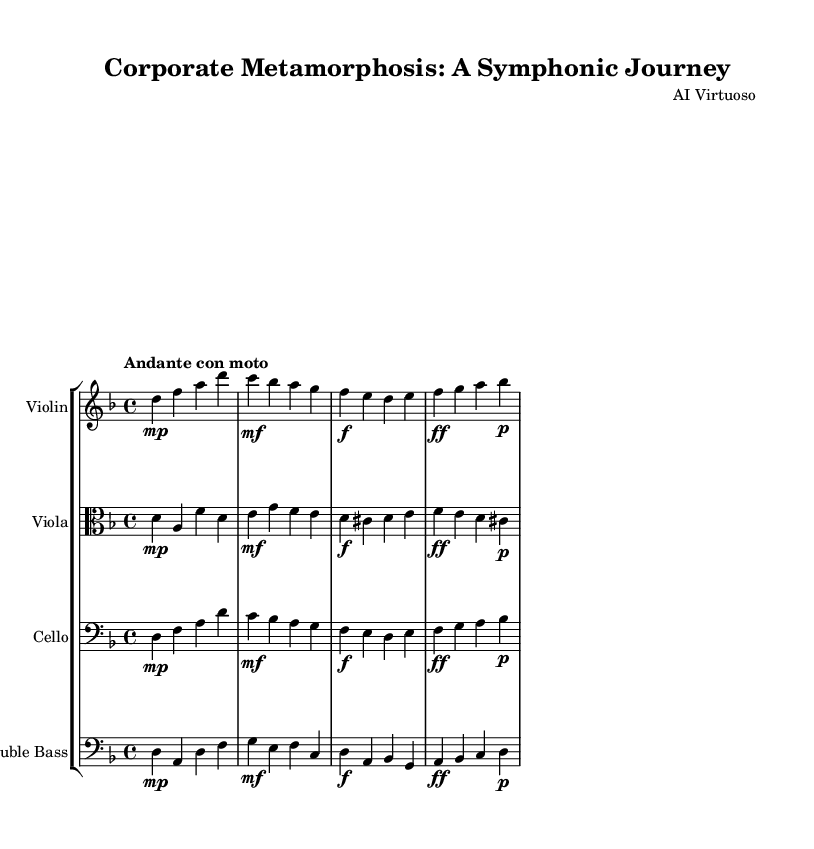what is the key signature of this music? The key signature is indicated near the beginning of the score. In this case, it shows a flat sign, indicating B flat. This corresponds to the key of D minor which has one flat.
Answer: D minor what is the time signature of this music? The time signature is displayed at the beginning of the score, where it shows a '4' over a '4', meaning there are four beats in a measure and each quarter note gets one beat.
Answer: 4/4 what is the tempo marking of this music? The tempo marking is written above the staff following the global section. It reads "Andante con moto," which translates to a moderately slow pace.
Answer: Andante con moto how many instruments are featured in this symphony? To determine this, you can count the number of staves in the score. Each staff represents a different instrument. In this case, there are four staves for four instruments.
Answer: Four which instrument plays the highest pitch in this symphony? The highest pitch is determined by analyzing the range of each instrument. The Violin typically plays at the highest pitch compared to Viola, Cello, and Double Bass, which play lower.
Answer: Violin what kind of musical form is primarily used in this symphony? The musical form can be inferred from the structure of the sections in the score. This symphony exhibits a theme and variations structure, showcasing the evolution of leadership styles as thematic material is developed.
Answer: Theme and variations which instrument has the melody in the first section? By examining the melody line indicated in the score, the Violin is the one primarily carrying the melodic content in the first section, while other instruments support harmonically.
Answer: Violin 